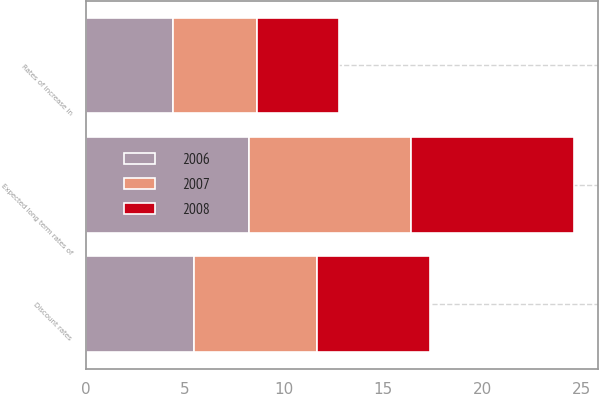Convert chart to OTSL. <chart><loc_0><loc_0><loc_500><loc_500><stacked_bar_chart><ecel><fcel>Discount rates<fcel>Rates of increase in<fcel>Expected long term rates of<nl><fcel>2007<fcel>6.17<fcel>4.22<fcel>8.2<nl><fcel>2008<fcel>5.74<fcel>4.14<fcel>8.21<nl><fcel>2006<fcel>5.46<fcel>4.41<fcel>8.2<nl></chart> 